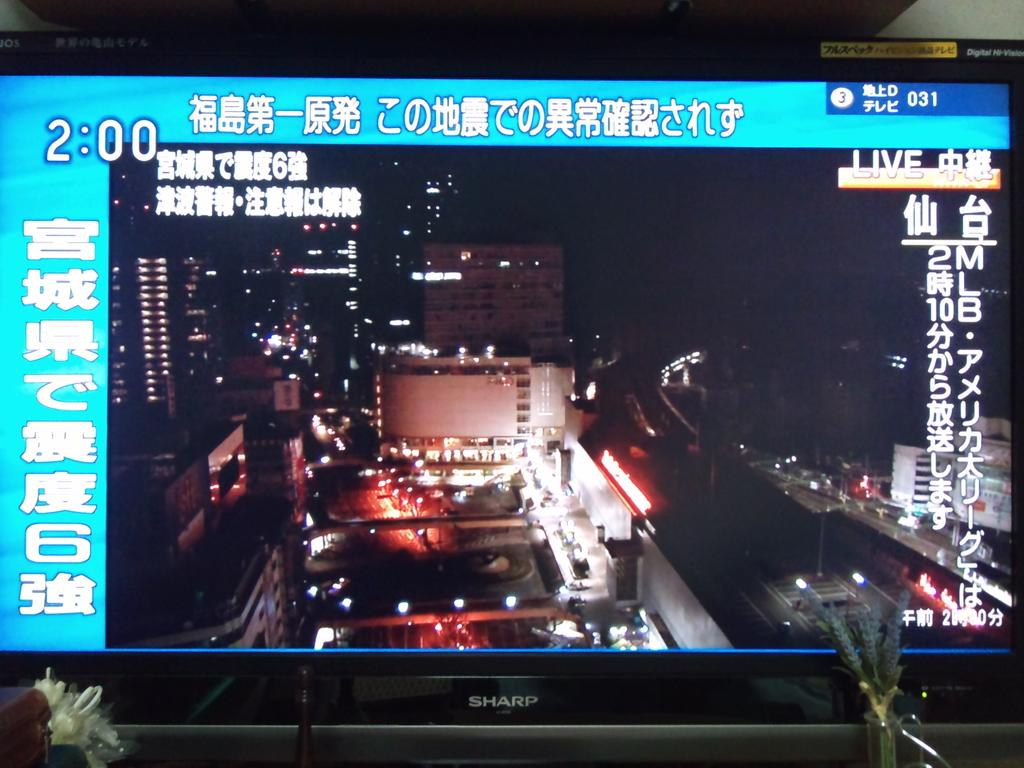<image>
Create a compact narrative representing the image presented. A Sharp monitor shows that it is currently 2:00. 